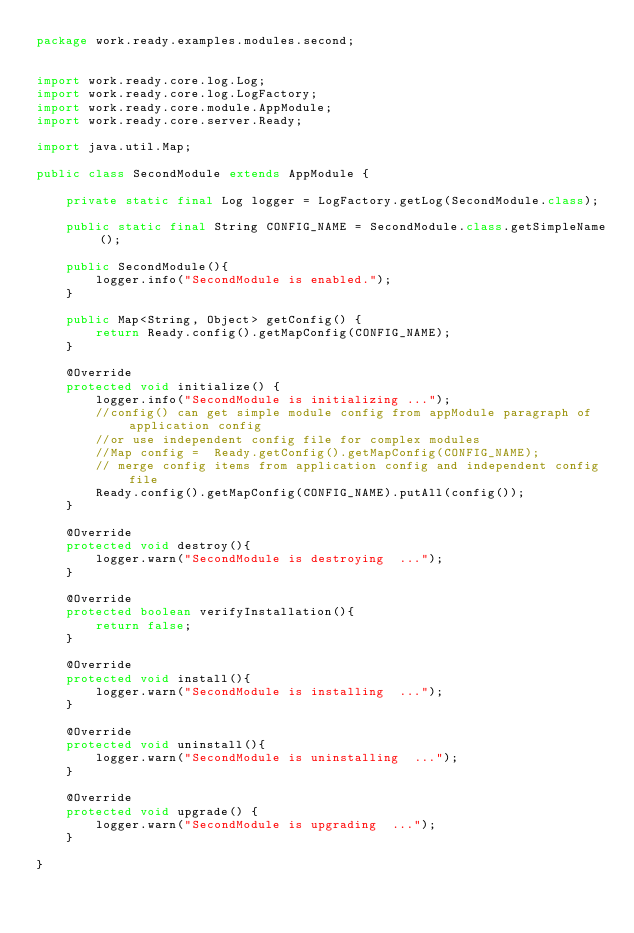<code> <loc_0><loc_0><loc_500><loc_500><_Java_>package work.ready.examples.modules.second;


import work.ready.core.log.Log;
import work.ready.core.log.LogFactory;
import work.ready.core.module.AppModule;
import work.ready.core.server.Ready;

import java.util.Map;

public class SecondModule extends AppModule {

    private static final Log logger = LogFactory.getLog(SecondModule.class);

    public static final String CONFIG_NAME = SecondModule.class.getSimpleName();

    public SecondModule(){
        logger.info("SecondModule is enabled.");
    }

    public Map<String, Object> getConfig() {
        return Ready.config().getMapConfig(CONFIG_NAME);
    }

    @Override
    protected void initialize() {
        logger.info("SecondModule is initializing ...");
        //config() can get simple module config from appModule paragraph of application config
        //or use independent config file for complex modules
        //Map config =  Ready.getConfig().getMapConfig(CONFIG_NAME);
        // merge config items from application config and independent config file
        Ready.config().getMapConfig(CONFIG_NAME).putAll(config());
    }

    @Override
    protected void destroy(){
        logger.warn("SecondModule is destroying  ...");
    }

    @Override
    protected boolean verifyInstallation(){
        return false;
    }

    @Override
    protected void install(){
        logger.warn("SecondModule is installing  ...");
    }

    @Override
    protected void uninstall(){
        logger.warn("SecondModule is uninstalling  ...");
    }

    @Override
    protected void upgrade() {
        logger.warn("SecondModule is upgrading  ...");
    }

}
</code> 